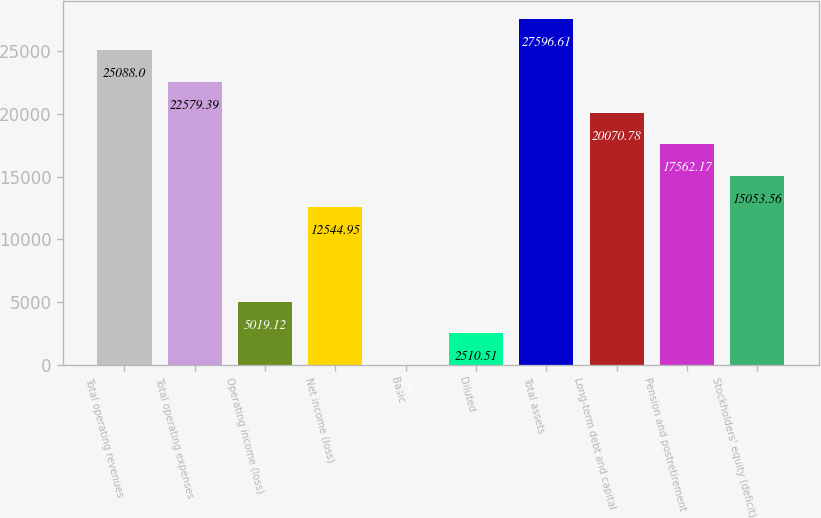Convert chart. <chart><loc_0><loc_0><loc_500><loc_500><bar_chart><fcel>Total operating revenues<fcel>Total operating expenses<fcel>Operating income (loss)<fcel>Net income (loss)<fcel>Basic<fcel>Diluted<fcel>Total assets<fcel>Long-term debt and capital<fcel>Pension and postretirement<fcel>Stockholders' equity (deficit)<nl><fcel>25088<fcel>22579.4<fcel>5019.12<fcel>12545<fcel>1.9<fcel>2510.51<fcel>27596.6<fcel>20070.8<fcel>17562.2<fcel>15053.6<nl></chart> 